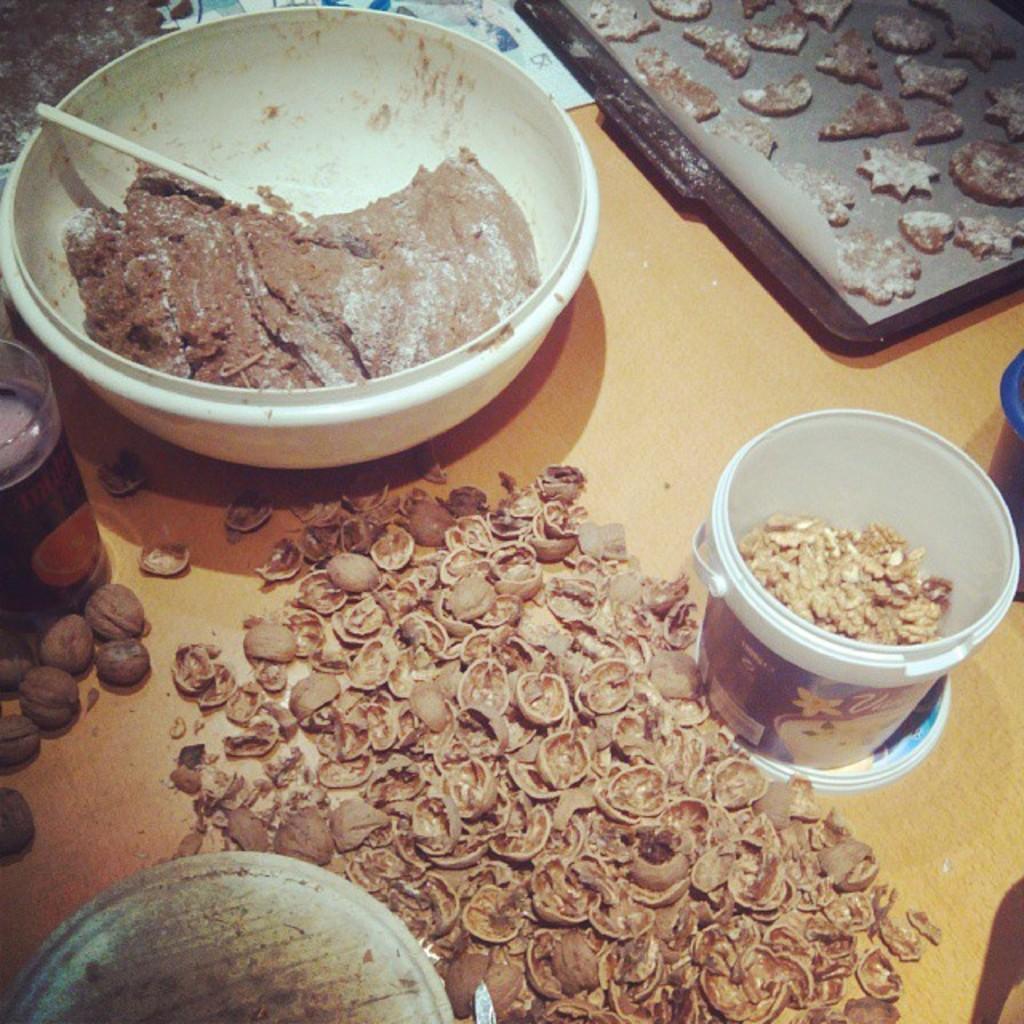Describe this image in one or two sentences. In this image we can see walnut shell on the wooden surface. In one bucket walnut is there. At the bottom of the image, one circular shaped thing is present. At the left top of the image one glass is there. In glass some juice is present. And we can see brown color dough in a white color bowl. Right top of the image, biscuits are there in a brown tray. 